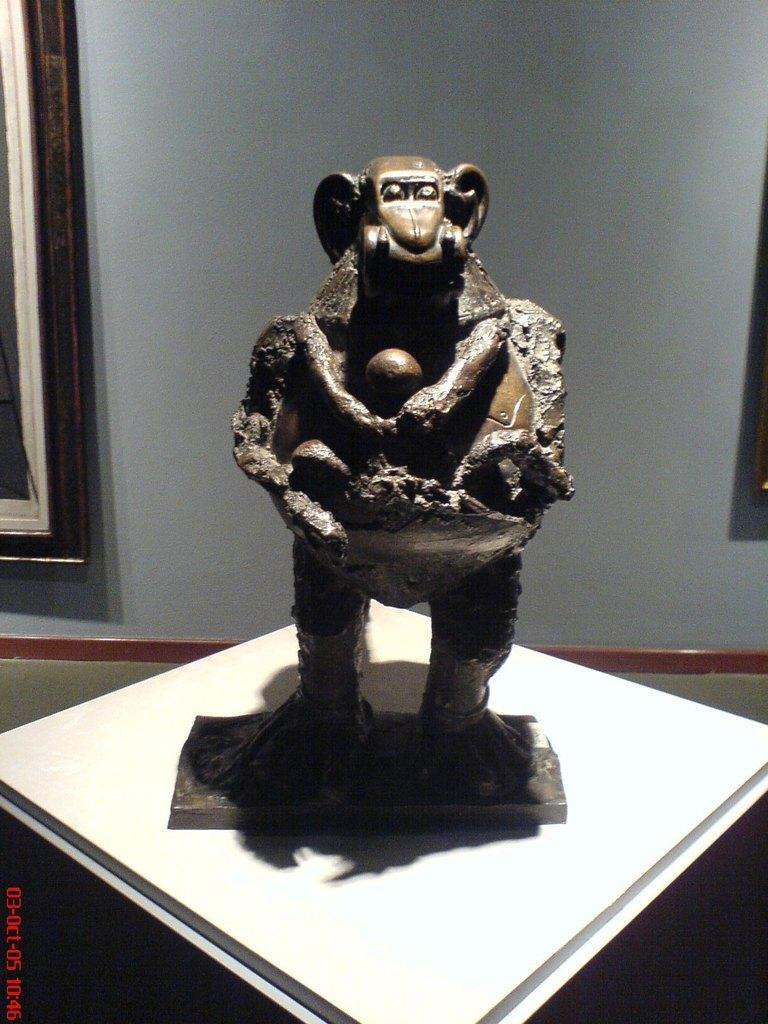What is placed on the table in the image? There is a sculpture on the table. What can be seen in the background of the image? There are wall hangings in the background. What type of pin is holding the sculpture together in the image? There is no pin visible in the image, and the sculpture does not appear to be held together by any visible means. 